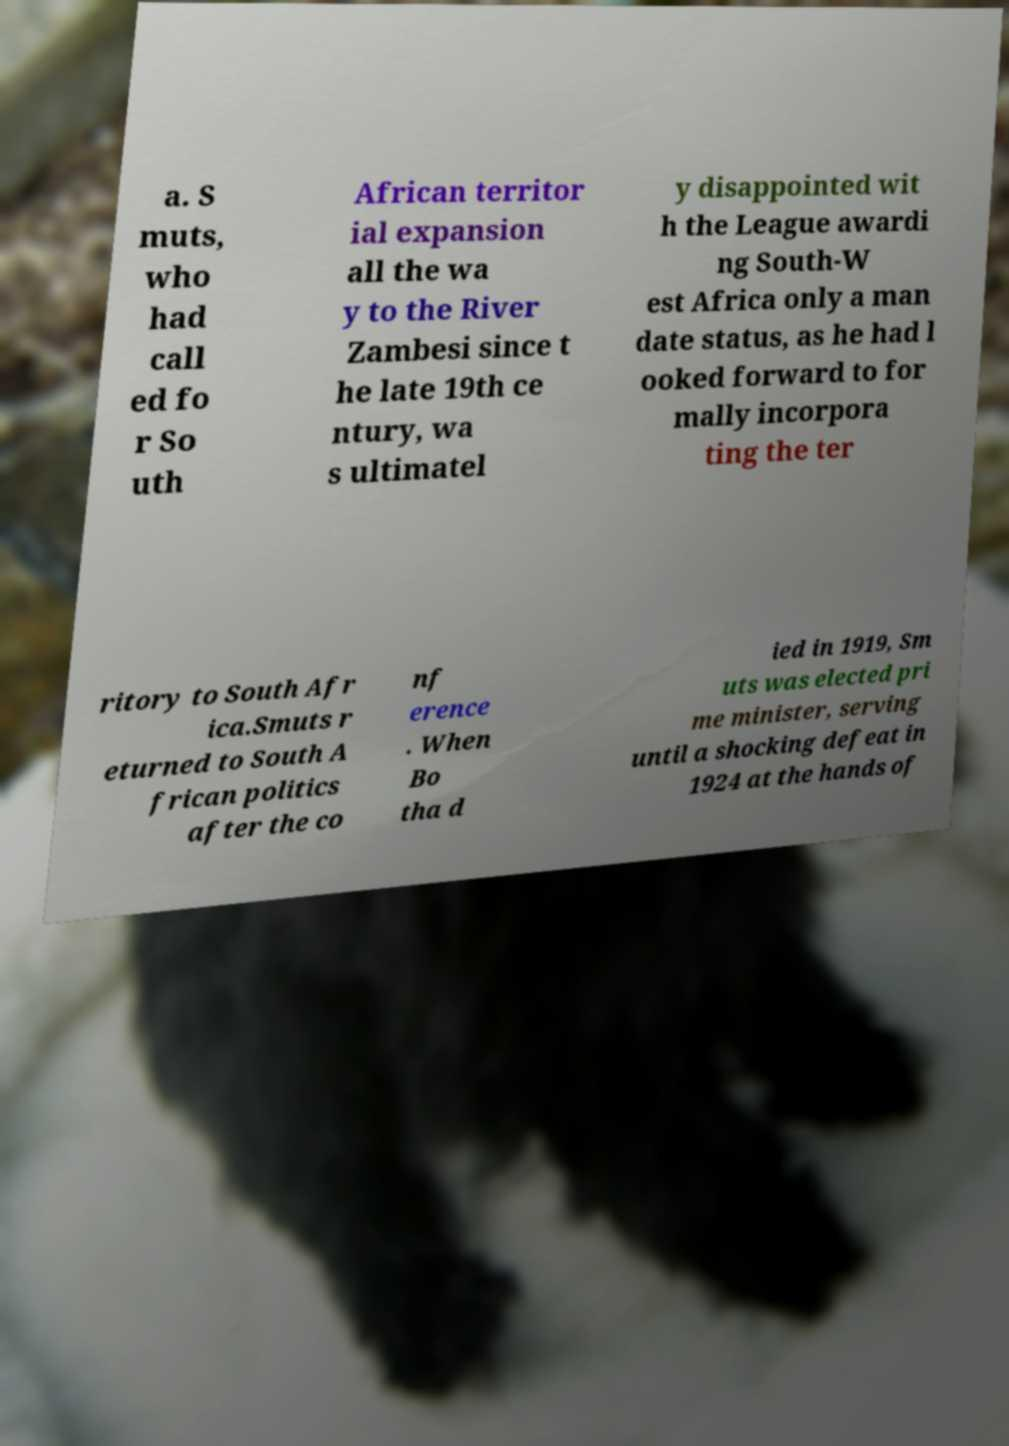I need the written content from this picture converted into text. Can you do that? a. S muts, who had call ed fo r So uth African territor ial expansion all the wa y to the River Zambesi since t he late 19th ce ntury, wa s ultimatel y disappointed wit h the League awardi ng South-W est Africa only a man date status, as he had l ooked forward to for mally incorpora ting the ter ritory to South Afr ica.Smuts r eturned to South A frican politics after the co nf erence . When Bo tha d ied in 1919, Sm uts was elected pri me minister, serving until a shocking defeat in 1924 at the hands of 